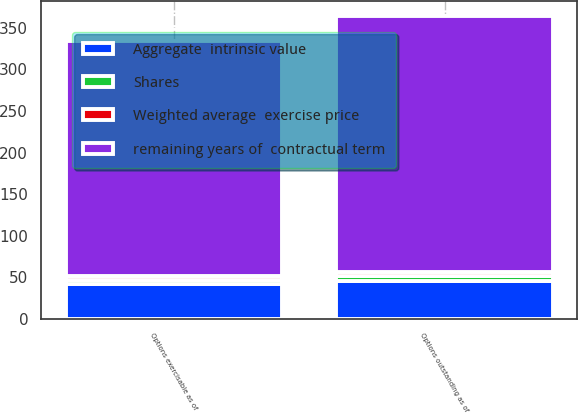<chart> <loc_0><loc_0><loc_500><loc_500><stacked_bar_chart><ecel><fcel>Options outstanding as of<fcel>Options exercisable as of<nl><fcel>Shares<fcel>5.8<fcel>5<nl><fcel>Aggregate  intrinsic value<fcel>45.61<fcel>42.1<nl><fcel>Weighted average  exercise price<fcel>4.5<fcel>4<nl><fcel>remaining years of  contractual term<fcel>308<fcel>283<nl></chart> 